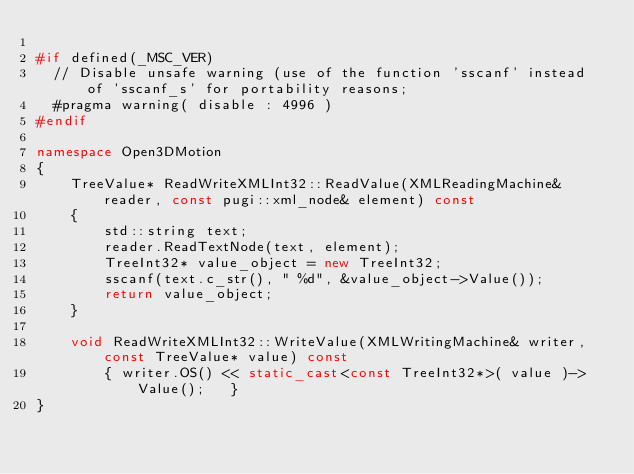<code> <loc_0><loc_0><loc_500><loc_500><_C++_>
#if defined(_MSC_VER)
  // Disable unsafe warning (use of the function 'sscanf' instead of 'sscanf_s' for portability reasons;
  #pragma warning( disable : 4996 )
#endif

namespace Open3DMotion
{
	TreeValue* ReadWriteXMLInt32::ReadValue(XMLReadingMachine& reader, const pugi::xml_node& element) const
	{
		std::string text;
		reader.ReadTextNode(text, element);
		TreeInt32* value_object = new TreeInt32;
		sscanf(text.c_str(), " %d", &value_object->Value());
		return value_object;
	}
	
	void ReadWriteXMLInt32::WriteValue(XMLWritingMachine& writer, const TreeValue* value) const
		{ writer.OS() << static_cast<const TreeInt32*>( value )->Value();	}
}
</code> 